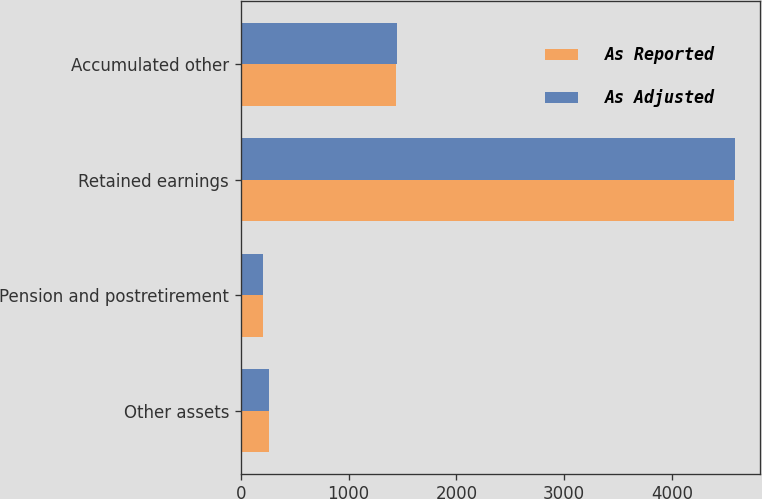Convert chart. <chart><loc_0><loc_0><loc_500><loc_500><stacked_bar_chart><ecel><fcel>Other assets<fcel>Pension and postretirement<fcel>Retained earnings<fcel>Accumulated other<nl><fcel>As Reported<fcel>264.1<fcel>208.9<fcel>4570.4<fcel>1437.9<nl><fcel>As Adjusted<fcel>266.2<fcel>208.3<fcel>4585<fcel>1449.8<nl></chart> 